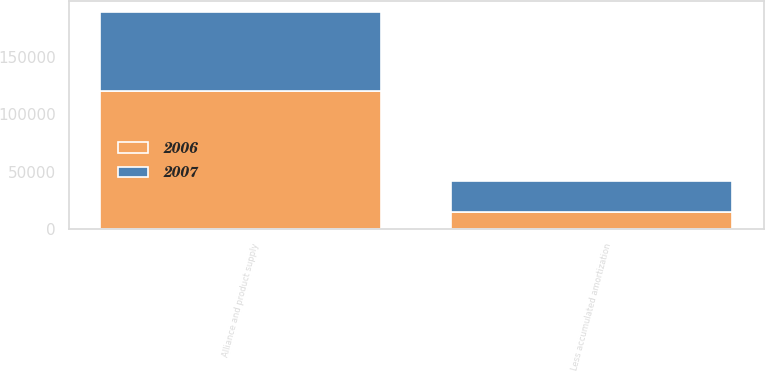Convert chart to OTSL. <chart><loc_0><loc_0><loc_500><loc_500><stacked_bar_chart><ecel><fcel>Alliance and product supply<fcel>Less accumulated amortization<nl><fcel>2007<fcel>68200<fcel>26893<nl><fcel>2006<fcel>120300<fcel>15037<nl></chart> 